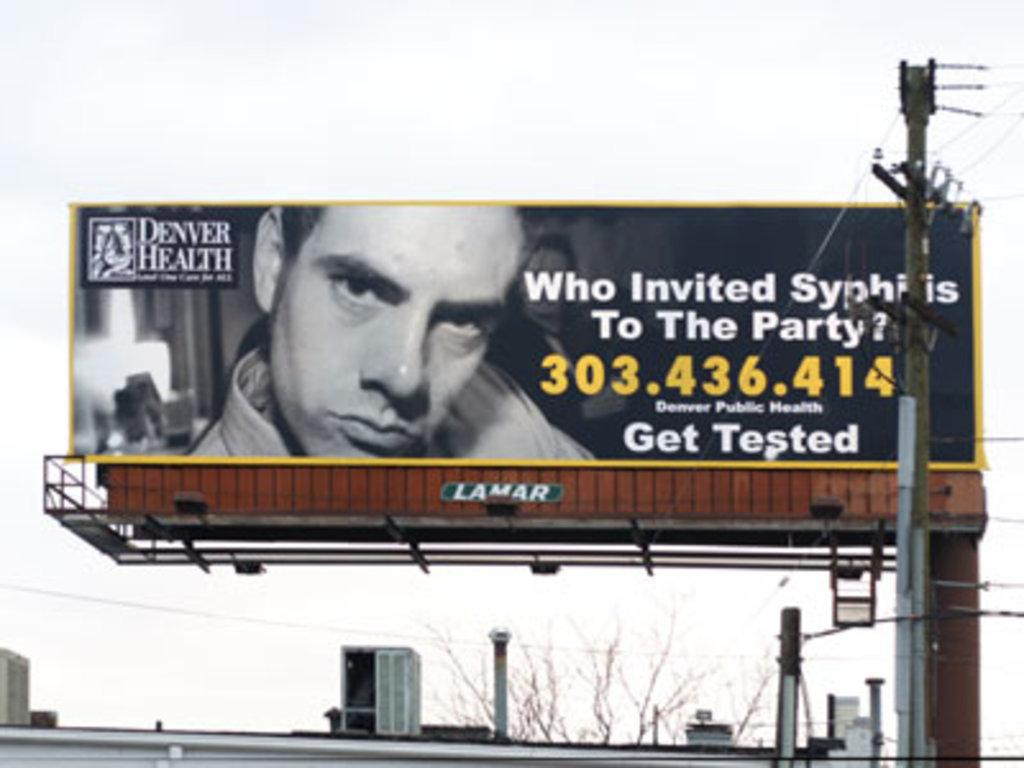Provide a one-sentence caption for the provided image. An advertisement regarding STDs is on a billboard with a phone number to contact. 